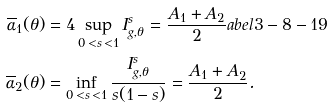<formula> <loc_0><loc_0><loc_500><loc_500>\overline { \alpha } _ { 1 } ( \theta ) & = 4 \sup _ { 0 \, < s \, < 1 } I ^ { s } _ { g , \theta } = \frac { A _ { 1 } + A _ { 2 } } { 2 } \L a b e l { 3 - 8 - 1 9 } \\ \overline { \alpha } _ { 2 } ( \theta ) & = \inf _ { 0 \, < s \, < 1 } \frac { I ^ { s } _ { g , \theta } } { s ( 1 - s ) } = \frac { A _ { 1 } + A _ { 2 } } { 2 } .</formula> 